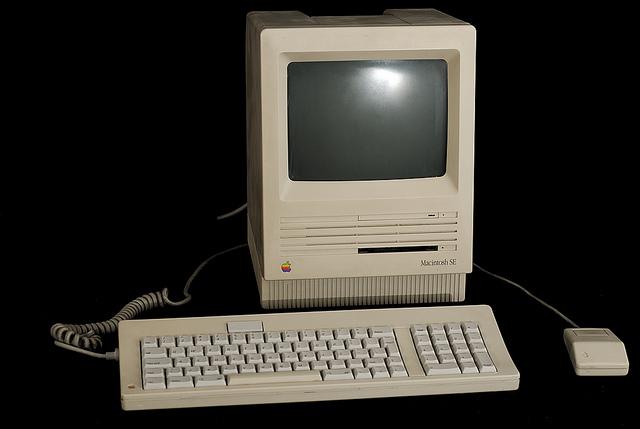Is this a laptop?
Concise answer only. No. Is the computer on?
Be succinct. No. Is the mouse wireless?
Keep it brief. No. How many keyboards are in the picture?
Write a very short answer. 1. Was the computer on fire?
Answer briefly. No. What model Apple computer is this?
Concise answer only. Macintosh. Were all of these computer accessories purchased from the same place?
Give a very brief answer. Yes. Has the laptop been turned off?
Answer briefly. Yes. What color is the computer?
Write a very short answer. White. Who makes this item?
Keep it brief. Apple. How old are these computers?
Short answer required. 30 years. What device is on the table?
Be succinct. Computer. Is that an old TV?
Give a very brief answer. No. What is the brand of the computer?
Be succinct. Apple. Can the entire keyboard be seen?
Write a very short answer. Yes. Is this a new computer?
Answer briefly. No. What brand is this computer?
Give a very brief answer. Apple. Are those computers on?
Write a very short answer. No. 